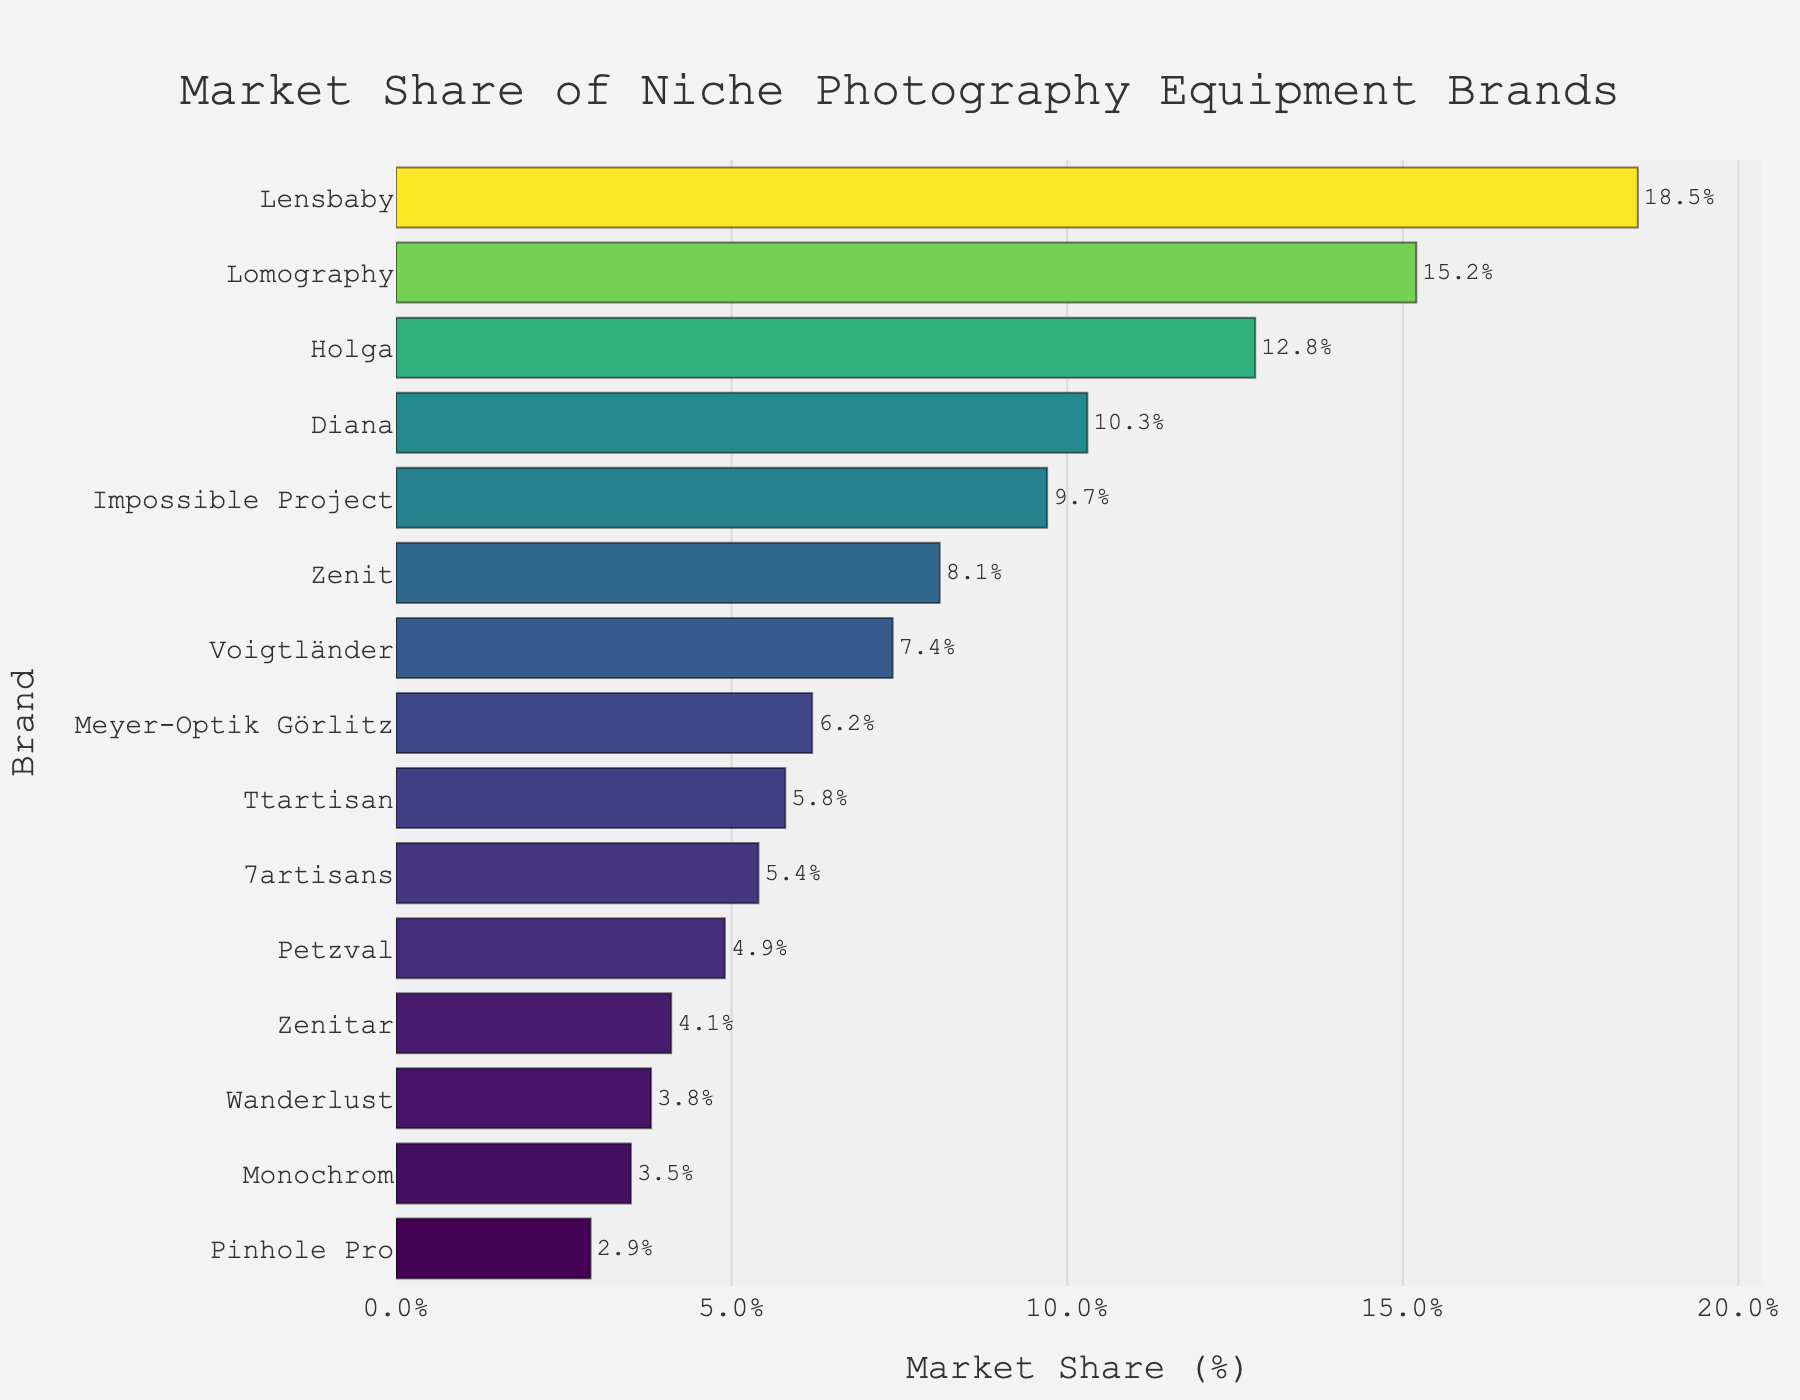Which brand has the highest market share? The brand with the highest market share is represented by the longest bar. In this chart, it's Lensbaby.
Answer: Lensbaby What is the total market share of Lomography and Holga combined? To find the total market share for Lomography and Holga, simply add their market shares: Lomography (15.2%) + Holga (12.8%) = 28%.
Answer: 28% Which brand has a market share closest to 10%? Look for the bar whose length is closest to the 10% mark. Diana has a market share of 10.3%, which is closest to 10%.
Answer: Diana How many brands have a market share less than 5%? Count the number of bars that have lengths representing less than the 5% mark. The brands are Petzval, Zenitar, Wanderlust, Monochrom, and Pinhole Pro (5 brands in total).
Answer: 5 What is the difference in market share between the top brand and the bottom brand? Subtract the market share of the brand with the smallest share (Pinhole Pro, 2.9%) from the brand with the largest share (Lensbaby, 18.5%): 18.5% - 2.9% = 15.6%.
Answer: 15.6% Which brands have a market share between 5% and 10%? Identify the bars whose lengths fall between the 5% and 10% marks. The brands are Zenit (8.1%), Voigtländer (7.4%), Meyer-Optik Görlitz (6.2%), Ttartisan (5.8%), and 7artisans (5.4%).
Answer: Zenit, Voigtländer, Meyer-Optik Görlitz, Ttartisan, 7artisans Is the market share of Diana greater than the sum of Zenitar and Wanderlust? Calculate the sum of Zenitar (4.1%) and Wanderlust (3.8%): 4.1% + 3.8% = 7.9%. Compare this sum to Diana's market share (10.3%). Since 10.3% is greater than 7.9%, the answer is yes.
Answer: Yes What is the average market share of the top three brands? Calculate the average by summing the market shares of the top three brands (Lensbaby, Lomography, Holga) and dividing by three: (18.5% + 15.2% + 12.8%) / 3 = 15.5%.
Answer: 15.5% Which brand has a market share almost the same as the combination of Monochrom and Pinhole Pro? Add the market shares of Monochrom (3.5%) and Pinhole Pro (2.9%): 3.5% + 2.9% = 6.4%. Meyer-Optik Görlitz has a market share of 6.2%, which is very close to 6.4%.
Answer: Meyer-Optik Görlitz Compare the market share of Voigtländer and Diana. Which one is higher, and by how much? Subtract the market share of Voigtländer (7.4%) from Diana (10.3%): 10.3% - 7.4% = 2.9%. Diana's market share is higher by 2.9%.
Answer: Diana, 2.9% 